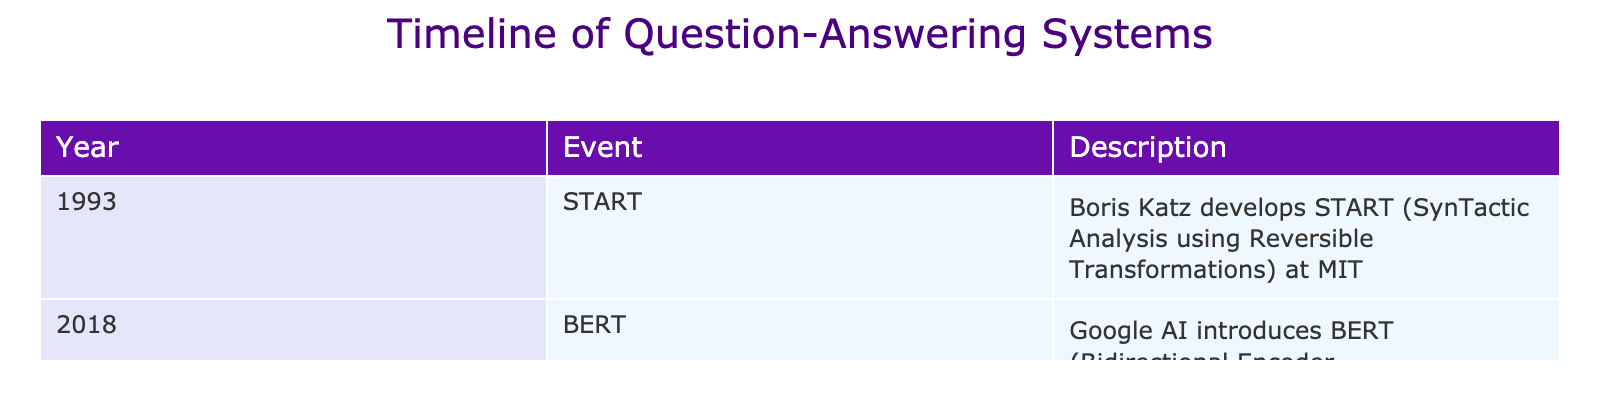What year did Boris Katz develop the START system? The table lists events alongside their corresponding years. The START system is in the event column, which indicates that it was developed in 1993.
Answer: 1993 Which system was introduced by Google AI in 2018? By checking the event column for the year 2018, we find that BERT (Bidirectional Encoder Representations from Transformers) is the system introduced by Google AI.
Answer: BERT Is BERT an advancement in question-answering systems? By looking at the description for BERT in the table, which specifies it as a system from Google AI aimed at natural language understanding, it can be concluded that it is indeed an advancement in this field.
Answer: Yes What is the time gap between the START system and BERT? The START system was developed in 1993 and BERT was introduced in 2018. Therefore, to calculate the time gap, we subtract 1993 from 2018, which gives us 25 years.
Answer: 25 years Was any other significant system mentioned between the years of 1993 and 2018 in the timeline? The table only includes the START system in 1993 and BERT in 2018, with no other significant systems or events listed for the intervening years, thus confirming none are mentioned.
Answer: No What event signifies the beginning of the timeline, and what year does it correspond to? The timeline begins with the START system developed by Boris Katz, which corresponds to the year 1993. This answer is derived directly from the first row of the table.
Answer: START in 1993 In how many years did the advancements occur as per the table? There are two events listed in the table: the START system in 1993 and BERT in 2018. The time period from 1993 to 2018 is 25 years. Therefore, advancements occurred over a span of 25 years.
Answer: 25 years What does BERT stand for? Referring to the description in the table, BERT stands for Bidirectional Encoder Representations from Transformers as specified under its event entry.
Answer: Bidirectional Encoder Representations from Transformers 